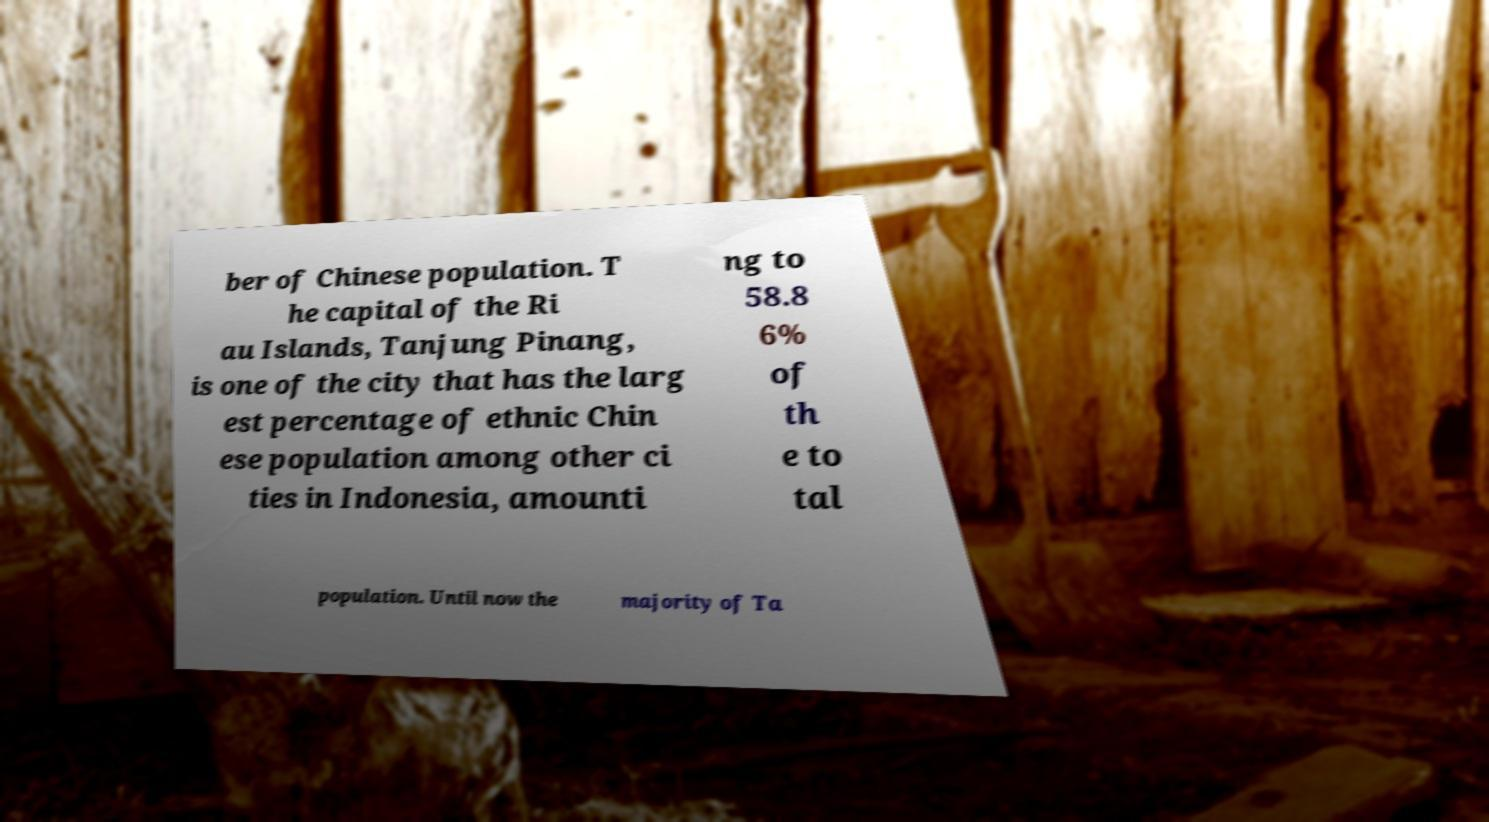What messages or text are displayed in this image? I need them in a readable, typed format. ber of Chinese population. T he capital of the Ri au Islands, Tanjung Pinang, is one of the city that has the larg est percentage of ethnic Chin ese population among other ci ties in Indonesia, amounti ng to 58.8 6% of th e to tal population. Until now the majority of Ta 